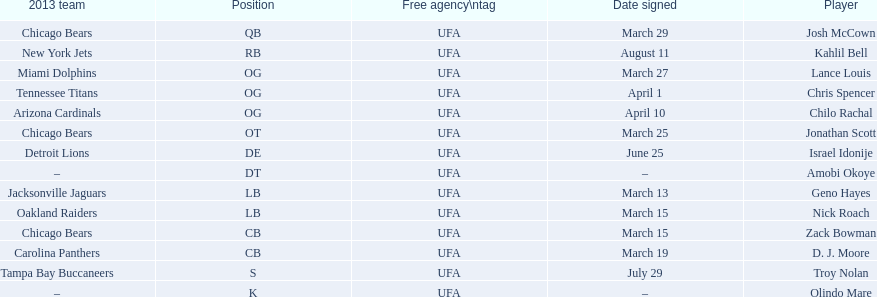Can you provide a last name that doubles as a first name and starts with the letter "n"? Troy Nolan. 